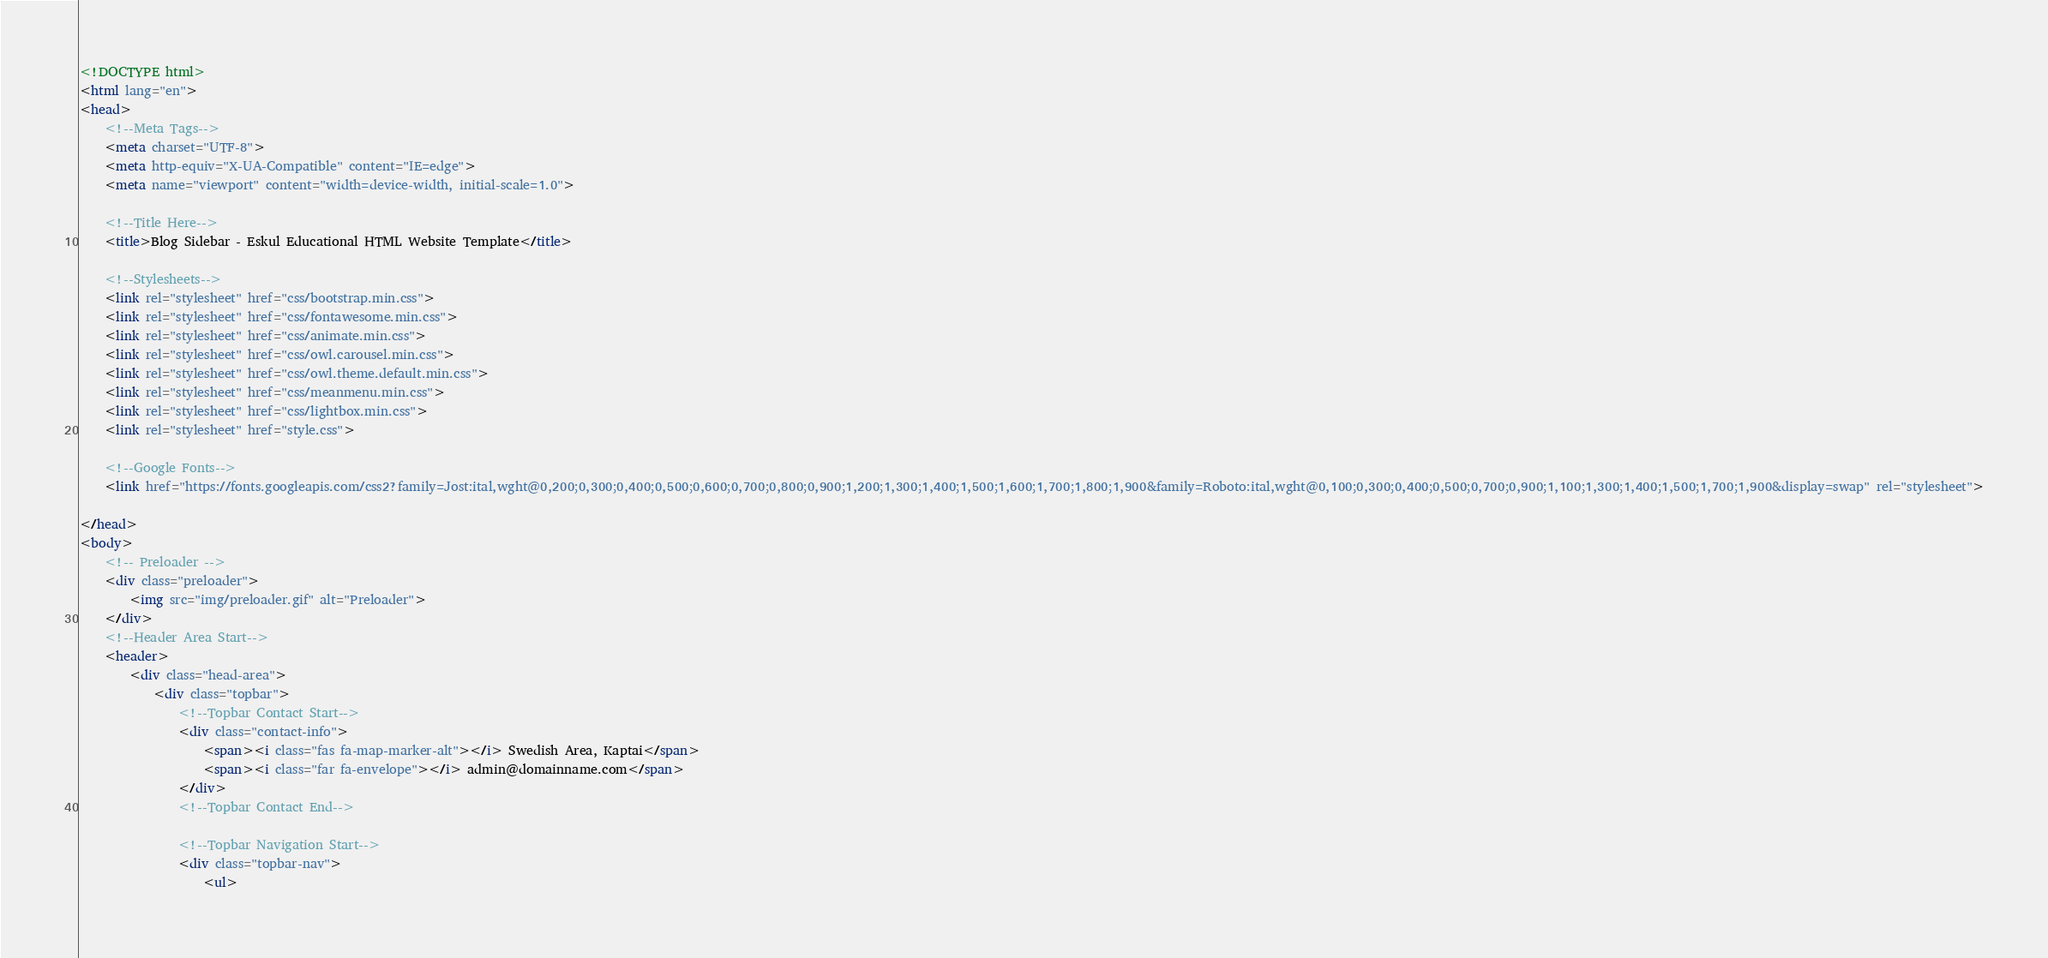<code> <loc_0><loc_0><loc_500><loc_500><_HTML_><!DOCTYPE html>
<html lang="en">
<head>
    <!--Meta Tags-->
    <meta charset="UTF-8">
    <meta http-equiv="X-UA-Compatible" content="IE=edge">
    <meta name="viewport" content="width=device-width, initial-scale=1.0">

    <!--Title Here-->
    <title>Blog Sidebar - Eskul Educational HTML Website Template</title>

    <!--Stylesheets-->
    <link rel="stylesheet" href="css/bootstrap.min.css">
    <link rel="stylesheet" href="css/fontawesome.min.css">
    <link rel="stylesheet" href="css/animate.min.css">
    <link rel="stylesheet" href="css/owl.carousel.min.css">
    <link rel="stylesheet" href="css/owl.theme.default.min.css">
    <link rel="stylesheet" href="css/meanmenu.min.css">
    <link rel="stylesheet" href="css/lightbox.min.css">
    <link rel="stylesheet" href="style.css">

    <!--Google Fonts-->
    <link href="https://fonts.googleapis.com/css2?family=Jost:ital,wght@0,200;0,300;0,400;0,500;0,600;0,700;0,800;0,900;1,200;1,300;1,400;1,500;1,600;1,700;1,800;1,900&family=Roboto:ital,wght@0,100;0,300;0,400;0,500;0,700;0,900;1,100;1,300;1,400;1,500;1,700;1,900&display=swap" rel="stylesheet">
    
</head>
<body>
    <!-- Preloader -->
	<div class="preloader">
		<img src="img/preloader.gif" alt="Preloader">
	</div>
    <!--Header Area Start-->
    <header>
        <div class="head-area">
            <div class="topbar">
                <!--Topbar Contact Start-->
                <div class="contact-info">
                    <span><i class="fas fa-map-marker-alt"></i> Swedish Area, Kaptai</span>
                    <span><i class="far fa-envelope"></i> admin@domainname.com</span>
                </div>
                <!--Topbar Contact End-->
        
                <!--Topbar Navigation Start--> 
                <div class="topbar-nav">
                    <ul></code> 